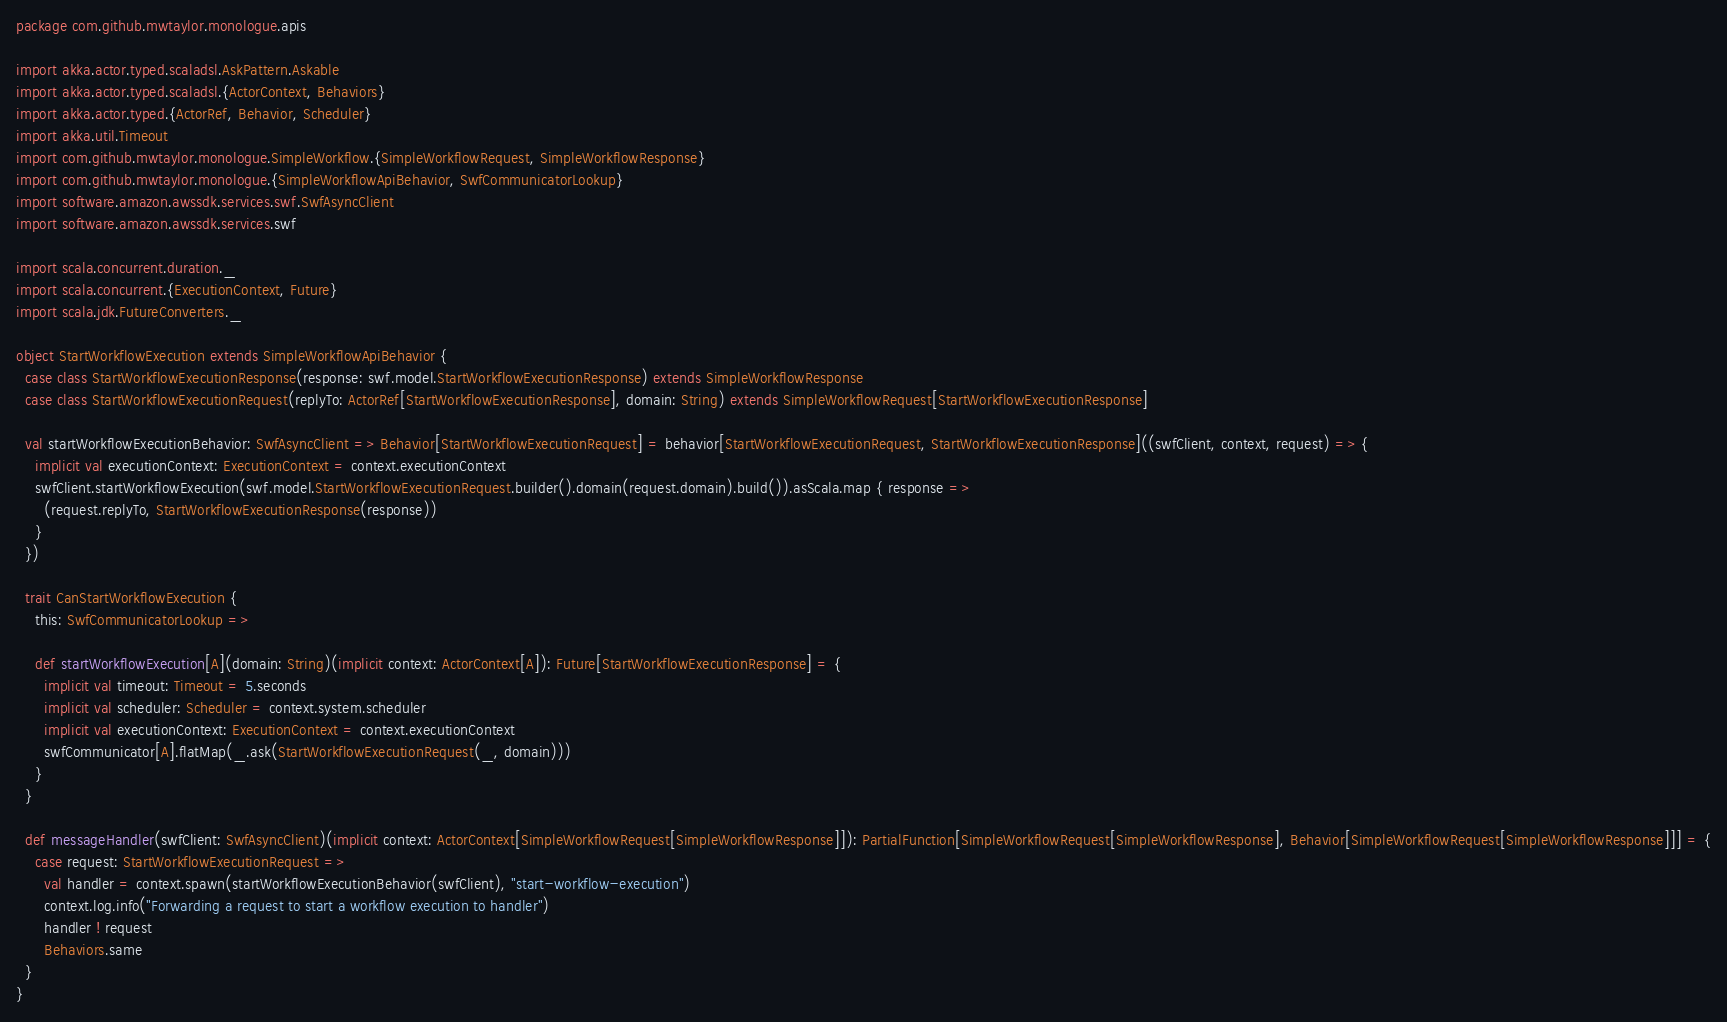Convert code to text. <code><loc_0><loc_0><loc_500><loc_500><_Scala_>package com.github.mwtaylor.monologue.apis

import akka.actor.typed.scaladsl.AskPattern.Askable
import akka.actor.typed.scaladsl.{ActorContext, Behaviors}
import akka.actor.typed.{ActorRef, Behavior, Scheduler}
import akka.util.Timeout
import com.github.mwtaylor.monologue.SimpleWorkflow.{SimpleWorkflowRequest, SimpleWorkflowResponse}
import com.github.mwtaylor.monologue.{SimpleWorkflowApiBehavior, SwfCommunicatorLookup}
import software.amazon.awssdk.services.swf.SwfAsyncClient
import software.amazon.awssdk.services.swf

import scala.concurrent.duration._
import scala.concurrent.{ExecutionContext, Future}
import scala.jdk.FutureConverters._

object StartWorkflowExecution extends SimpleWorkflowApiBehavior {
  case class StartWorkflowExecutionResponse(response: swf.model.StartWorkflowExecutionResponse) extends SimpleWorkflowResponse
  case class StartWorkflowExecutionRequest(replyTo: ActorRef[StartWorkflowExecutionResponse], domain: String) extends SimpleWorkflowRequest[StartWorkflowExecutionResponse]

  val startWorkflowExecutionBehavior: SwfAsyncClient => Behavior[StartWorkflowExecutionRequest] = behavior[StartWorkflowExecutionRequest, StartWorkflowExecutionResponse]((swfClient, context, request) => {
    implicit val executionContext: ExecutionContext = context.executionContext
    swfClient.startWorkflowExecution(swf.model.StartWorkflowExecutionRequest.builder().domain(request.domain).build()).asScala.map { response =>
      (request.replyTo, StartWorkflowExecutionResponse(response))
    }
  })

  trait CanStartWorkflowExecution {
    this: SwfCommunicatorLookup =>

    def startWorkflowExecution[A](domain: String)(implicit context: ActorContext[A]): Future[StartWorkflowExecutionResponse] = {
      implicit val timeout: Timeout = 5.seconds
      implicit val scheduler: Scheduler = context.system.scheduler
      implicit val executionContext: ExecutionContext = context.executionContext
      swfCommunicator[A].flatMap(_.ask(StartWorkflowExecutionRequest(_, domain)))
    }
  }

  def messageHandler(swfClient: SwfAsyncClient)(implicit context: ActorContext[SimpleWorkflowRequest[SimpleWorkflowResponse]]): PartialFunction[SimpleWorkflowRequest[SimpleWorkflowResponse], Behavior[SimpleWorkflowRequest[SimpleWorkflowResponse]]] = {
    case request: StartWorkflowExecutionRequest =>
      val handler = context.spawn(startWorkflowExecutionBehavior(swfClient), "start-workflow-execution")
      context.log.info("Forwarding a request to start a workflow execution to handler")
      handler ! request
      Behaviors.same
  }
}
</code> 